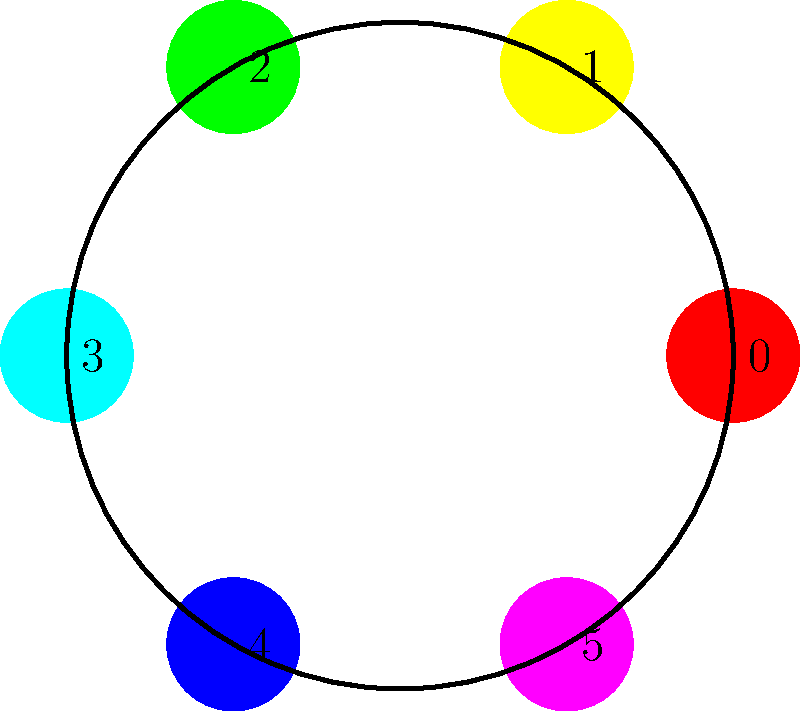In a painting workshop for seniors, you're using a color wheel with six primary and secondary colors arranged in a circle. The colors are numbered from 0 to 5 in clockwise order, starting with red at 0. If you apply the group operation of rotating the wheel by one position clockwise, what would be the result of the operation $(3 + 4) \mod 6$ in this cyclic group? Let's approach this step-by-step:

1) In this cyclic group of order 6, the elements are $\{0, 1, 2, 3, 4, 5\}$, representing the colors in clockwise order from red.

2) The group operation is addition modulo 6, which corresponds to clockwise rotation.

3) We need to calculate $(3 + 4) \mod 6$:
   
   $3 + 4 = 7$
   
   $7 \mod 6 = 1$ (because 7 divided by 6 leaves a remainder of 1)

4) In the color wheel:
   - 3 represents cyan
   - 4 represents blue
   - 1 represents yellow

5) So, rotating cyan (3) by four positions clockwise, or equivalently, rotating blue (4) by three positions clockwise, both result in yellow (1).

This demonstrates the commutative property of cyclic groups: $3 + 4 = 4 + 3 = 1$ (mod 6).
Answer: 1 (Yellow) 